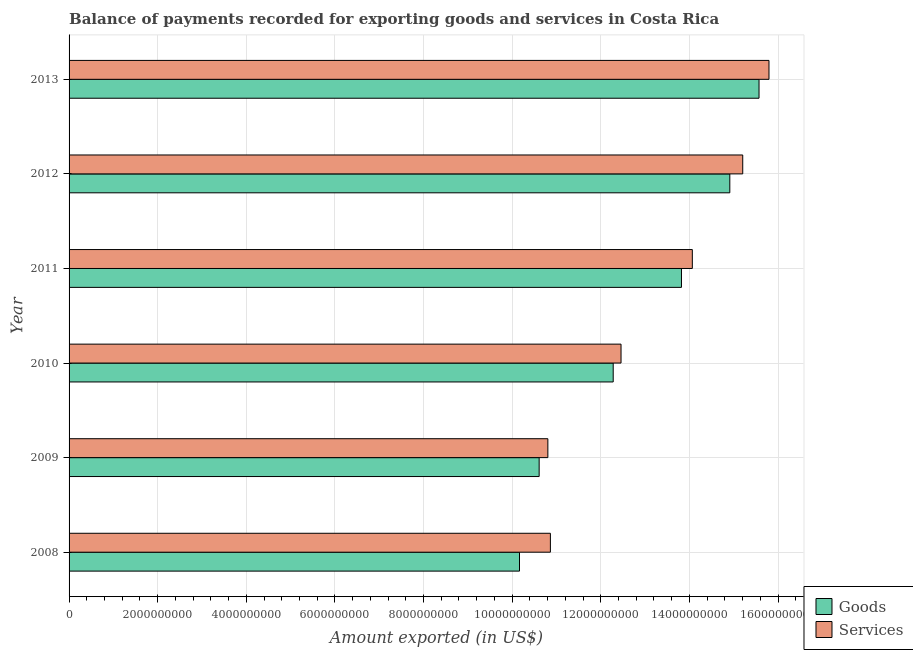How many groups of bars are there?
Provide a short and direct response. 6. How many bars are there on the 1st tick from the bottom?
Ensure brevity in your answer.  2. What is the amount of goods exported in 2011?
Your response must be concise. 1.38e+1. Across all years, what is the maximum amount of goods exported?
Offer a terse response. 1.56e+1. Across all years, what is the minimum amount of goods exported?
Ensure brevity in your answer.  1.02e+1. In which year was the amount of goods exported maximum?
Provide a short and direct response. 2013. What is the total amount of goods exported in the graph?
Your answer should be compact. 7.74e+1. What is the difference between the amount of services exported in 2009 and that in 2011?
Offer a terse response. -3.26e+09. What is the difference between the amount of goods exported in 2009 and the amount of services exported in 2011?
Offer a terse response. -3.46e+09. What is the average amount of goods exported per year?
Offer a very short reply. 1.29e+1. In the year 2009, what is the difference between the amount of services exported and amount of goods exported?
Offer a very short reply. 1.96e+08. In how many years, is the amount of goods exported greater than 2400000000 US$?
Offer a very short reply. 6. What is the ratio of the amount of goods exported in 2009 to that in 2012?
Your answer should be compact. 0.71. Is the amount of goods exported in 2009 less than that in 2010?
Provide a succinct answer. Yes. Is the difference between the amount of goods exported in 2011 and 2013 greater than the difference between the amount of services exported in 2011 and 2013?
Offer a terse response. No. What is the difference between the highest and the second highest amount of goods exported?
Your answer should be compact. 6.60e+08. What is the difference between the highest and the lowest amount of services exported?
Keep it short and to the point. 4.99e+09. In how many years, is the amount of services exported greater than the average amount of services exported taken over all years?
Offer a very short reply. 3. What does the 1st bar from the top in 2010 represents?
Keep it short and to the point. Services. What does the 1st bar from the bottom in 2008 represents?
Provide a short and direct response. Goods. How many bars are there?
Ensure brevity in your answer.  12. How many legend labels are there?
Make the answer very short. 2. What is the title of the graph?
Your answer should be very brief. Balance of payments recorded for exporting goods and services in Costa Rica. Does "Time to import" appear as one of the legend labels in the graph?
Your answer should be very brief. No. What is the label or title of the X-axis?
Provide a succinct answer. Amount exported (in US$). What is the Amount exported (in US$) of Goods in 2008?
Offer a terse response. 1.02e+1. What is the Amount exported (in US$) of Services in 2008?
Give a very brief answer. 1.09e+1. What is the Amount exported (in US$) in Goods in 2009?
Give a very brief answer. 1.06e+1. What is the Amount exported (in US$) in Services in 2009?
Your response must be concise. 1.08e+1. What is the Amount exported (in US$) in Goods in 2010?
Ensure brevity in your answer.  1.23e+1. What is the Amount exported (in US$) in Services in 2010?
Your answer should be very brief. 1.25e+1. What is the Amount exported (in US$) of Goods in 2011?
Provide a succinct answer. 1.38e+1. What is the Amount exported (in US$) in Services in 2011?
Your response must be concise. 1.41e+1. What is the Amount exported (in US$) of Goods in 2012?
Ensure brevity in your answer.  1.49e+1. What is the Amount exported (in US$) in Services in 2012?
Keep it short and to the point. 1.52e+1. What is the Amount exported (in US$) in Goods in 2013?
Provide a short and direct response. 1.56e+1. What is the Amount exported (in US$) in Services in 2013?
Make the answer very short. 1.58e+1. Across all years, what is the maximum Amount exported (in US$) of Goods?
Provide a short and direct response. 1.56e+1. Across all years, what is the maximum Amount exported (in US$) of Services?
Provide a short and direct response. 1.58e+1. Across all years, what is the minimum Amount exported (in US$) of Goods?
Give a very brief answer. 1.02e+1. Across all years, what is the minimum Amount exported (in US$) of Services?
Make the answer very short. 1.08e+1. What is the total Amount exported (in US$) of Goods in the graph?
Your answer should be very brief. 7.74e+1. What is the total Amount exported (in US$) of Services in the graph?
Keep it short and to the point. 7.92e+1. What is the difference between the Amount exported (in US$) in Goods in 2008 and that in 2009?
Your answer should be compact. -4.43e+08. What is the difference between the Amount exported (in US$) in Services in 2008 and that in 2009?
Your answer should be very brief. 5.70e+07. What is the difference between the Amount exported (in US$) in Goods in 2008 and that in 2010?
Offer a terse response. -2.11e+09. What is the difference between the Amount exported (in US$) of Services in 2008 and that in 2010?
Offer a terse response. -1.59e+09. What is the difference between the Amount exported (in US$) of Goods in 2008 and that in 2011?
Make the answer very short. -3.66e+09. What is the difference between the Amount exported (in US$) of Services in 2008 and that in 2011?
Give a very brief answer. -3.20e+09. What is the difference between the Amount exported (in US$) of Goods in 2008 and that in 2012?
Your answer should be compact. -4.75e+09. What is the difference between the Amount exported (in US$) in Services in 2008 and that in 2012?
Your answer should be very brief. -4.34e+09. What is the difference between the Amount exported (in US$) of Goods in 2008 and that in 2013?
Provide a short and direct response. -5.41e+09. What is the difference between the Amount exported (in US$) of Services in 2008 and that in 2013?
Offer a terse response. -4.93e+09. What is the difference between the Amount exported (in US$) of Goods in 2009 and that in 2010?
Give a very brief answer. -1.67e+09. What is the difference between the Amount exported (in US$) of Services in 2009 and that in 2010?
Your response must be concise. -1.65e+09. What is the difference between the Amount exported (in US$) in Goods in 2009 and that in 2011?
Provide a succinct answer. -3.21e+09. What is the difference between the Amount exported (in US$) of Services in 2009 and that in 2011?
Your response must be concise. -3.26e+09. What is the difference between the Amount exported (in US$) of Goods in 2009 and that in 2012?
Your answer should be compact. -4.30e+09. What is the difference between the Amount exported (in US$) in Services in 2009 and that in 2012?
Provide a succinct answer. -4.40e+09. What is the difference between the Amount exported (in US$) of Goods in 2009 and that in 2013?
Keep it short and to the point. -4.96e+09. What is the difference between the Amount exported (in US$) of Services in 2009 and that in 2013?
Give a very brief answer. -4.99e+09. What is the difference between the Amount exported (in US$) in Goods in 2010 and that in 2011?
Your response must be concise. -1.54e+09. What is the difference between the Amount exported (in US$) in Services in 2010 and that in 2011?
Your answer should be very brief. -1.61e+09. What is the difference between the Amount exported (in US$) in Goods in 2010 and that in 2012?
Provide a succinct answer. -2.63e+09. What is the difference between the Amount exported (in US$) in Services in 2010 and that in 2012?
Your answer should be compact. -2.75e+09. What is the difference between the Amount exported (in US$) of Goods in 2010 and that in 2013?
Give a very brief answer. -3.29e+09. What is the difference between the Amount exported (in US$) of Services in 2010 and that in 2013?
Your answer should be very brief. -3.34e+09. What is the difference between the Amount exported (in US$) in Goods in 2011 and that in 2012?
Keep it short and to the point. -1.09e+09. What is the difference between the Amount exported (in US$) of Services in 2011 and that in 2012?
Ensure brevity in your answer.  -1.14e+09. What is the difference between the Amount exported (in US$) in Goods in 2011 and that in 2013?
Ensure brevity in your answer.  -1.75e+09. What is the difference between the Amount exported (in US$) in Services in 2011 and that in 2013?
Give a very brief answer. -1.73e+09. What is the difference between the Amount exported (in US$) in Goods in 2012 and that in 2013?
Ensure brevity in your answer.  -6.60e+08. What is the difference between the Amount exported (in US$) of Services in 2012 and that in 2013?
Your answer should be very brief. -5.92e+08. What is the difference between the Amount exported (in US$) in Goods in 2008 and the Amount exported (in US$) in Services in 2009?
Ensure brevity in your answer.  -6.40e+08. What is the difference between the Amount exported (in US$) of Goods in 2008 and the Amount exported (in US$) of Services in 2010?
Provide a short and direct response. -2.29e+09. What is the difference between the Amount exported (in US$) of Goods in 2008 and the Amount exported (in US$) of Services in 2011?
Your answer should be very brief. -3.90e+09. What is the difference between the Amount exported (in US$) of Goods in 2008 and the Amount exported (in US$) of Services in 2012?
Your response must be concise. -5.04e+09. What is the difference between the Amount exported (in US$) in Goods in 2008 and the Amount exported (in US$) in Services in 2013?
Your response must be concise. -5.63e+09. What is the difference between the Amount exported (in US$) of Goods in 2009 and the Amount exported (in US$) of Services in 2010?
Your answer should be very brief. -1.85e+09. What is the difference between the Amount exported (in US$) of Goods in 2009 and the Amount exported (in US$) of Services in 2011?
Keep it short and to the point. -3.46e+09. What is the difference between the Amount exported (in US$) in Goods in 2009 and the Amount exported (in US$) in Services in 2012?
Your answer should be very brief. -4.59e+09. What is the difference between the Amount exported (in US$) of Goods in 2009 and the Amount exported (in US$) of Services in 2013?
Give a very brief answer. -5.19e+09. What is the difference between the Amount exported (in US$) in Goods in 2010 and the Amount exported (in US$) in Services in 2011?
Provide a succinct answer. -1.79e+09. What is the difference between the Amount exported (in US$) of Goods in 2010 and the Amount exported (in US$) of Services in 2012?
Your answer should be very brief. -2.92e+09. What is the difference between the Amount exported (in US$) of Goods in 2010 and the Amount exported (in US$) of Services in 2013?
Provide a succinct answer. -3.52e+09. What is the difference between the Amount exported (in US$) in Goods in 2011 and the Amount exported (in US$) in Services in 2012?
Make the answer very short. -1.38e+09. What is the difference between the Amount exported (in US$) in Goods in 2011 and the Amount exported (in US$) in Services in 2013?
Keep it short and to the point. -1.98e+09. What is the difference between the Amount exported (in US$) in Goods in 2012 and the Amount exported (in US$) in Services in 2013?
Your answer should be compact. -8.84e+08. What is the average Amount exported (in US$) of Goods per year?
Make the answer very short. 1.29e+1. What is the average Amount exported (in US$) of Services per year?
Provide a short and direct response. 1.32e+1. In the year 2008, what is the difference between the Amount exported (in US$) in Goods and Amount exported (in US$) in Services?
Offer a very short reply. -6.97e+08. In the year 2009, what is the difference between the Amount exported (in US$) of Goods and Amount exported (in US$) of Services?
Your response must be concise. -1.96e+08. In the year 2010, what is the difference between the Amount exported (in US$) of Goods and Amount exported (in US$) of Services?
Provide a succinct answer. -1.77e+08. In the year 2011, what is the difference between the Amount exported (in US$) of Goods and Amount exported (in US$) of Services?
Provide a short and direct response. -2.45e+08. In the year 2012, what is the difference between the Amount exported (in US$) of Goods and Amount exported (in US$) of Services?
Provide a succinct answer. -2.92e+08. In the year 2013, what is the difference between the Amount exported (in US$) of Goods and Amount exported (in US$) of Services?
Your response must be concise. -2.24e+08. What is the ratio of the Amount exported (in US$) in Goods in 2008 to that in 2009?
Keep it short and to the point. 0.96. What is the ratio of the Amount exported (in US$) of Services in 2008 to that in 2009?
Offer a very short reply. 1.01. What is the ratio of the Amount exported (in US$) of Goods in 2008 to that in 2010?
Provide a short and direct response. 0.83. What is the ratio of the Amount exported (in US$) in Services in 2008 to that in 2010?
Keep it short and to the point. 0.87. What is the ratio of the Amount exported (in US$) in Goods in 2008 to that in 2011?
Provide a short and direct response. 0.74. What is the ratio of the Amount exported (in US$) of Services in 2008 to that in 2011?
Provide a short and direct response. 0.77. What is the ratio of the Amount exported (in US$) in Goods in 2008 to that in 2012?
Ensure brevity in your answer.  0.68. What is the ratio of the Amount exported (in US$) in Services in 2008 to that in 2012?
Keep it short and to the point. 0.71. What is the ratio of the Amount exported (in US$) of Goods in 2008 to that in 2013?
Provide a succinct answer. 0.65. What is the ratio of the Amount exported (in US$) in Services in 2008 to that in 2013?
Provide a succinct answer. 0.69. What is the ratio of the Amount exported (in US$) in Goods in 2009 to that in 2010?
Offer a very short reply. 0.86. What is the ratio of the Amount exported (in US$) in Services in 2009 to that in 2010?
Your response must be concise. 0.87. What is the ratio of the Amount exported (in US$) in Goods in 2009 to that in 2011?
Your answer should be compact. 0.77. What is the ratio of the Amount exported (in US$) of Services in 2009 to that in 2011?
Give a very brief answer. 0.77. What is the ratio of the Amount exported (in US$) of Goods in 2009 to that in 2012?
Your response must be concise. 0.71. What is the ratio of the Amount exported (in US$) of Services in 2009 to that in 2012?
Give a very brief answer. 0.71. What is the ratio of the Amount exported (in US$) in Goods in 2009 to that in 2013?
Keep it short and to the point. 0.68. What is the ratio of the Amount exported (in US$) in Services in 2009 to that in 2013?
Offer a very short reply. 0.68. What is the ratio of the Amount exported (in US$) in Goods in 2010 to that in 2011?
Give a very brief answer. 0.89. What is the ratio of the Amount exported (in US$) of Services in 2010 to that in 2011?
Your response must be concise. 0.89. What is the ratio of the Amount exported (in US$) of Goods in 2010 to that in 2012?
Your answer should be very brief. 0.82. What is the ratio of the Amount exported (in US$) in Services in 2010 to that in 2012?
Give a very brief answer. 0.82. What is the ratio of the Amount exported (in US$) of Goods in 2010 to that in 2013?
Your answer should be very brief. 0.79. What is the ratio of the Amount exported (in US$) of Services in 2010 to that in 2013?
Offer a terse response. 0.79. What is the ratio of the Amount exported (in US$) of Goods in 2011 to that in 2012?
Ensure brevity in your answer.  0.93. What is the ratio of the Amount exported (in US$) in Services in 2011 to that in 2012?
Give a very brief answer. 0.93. What is the ratio of the Amount exported (in US$) of Goods in 2011 to that in 2013?
Provide a short and direct response. 0.89. What is the ratio of the Amount exported (in US$) of Services in 2011 to that in 2013?
Give a very brief answer. 0.89. What is the ratio of the Amount exported (in US$) in Goods in 2012 to that in 2013?
Provide a succinct answer. 0.96. What is the ratio of the Amount exported (in US$) of Services in 2012 to that in 2013?
Offer a very short reply. 0.96. What is the difference between the highest and the second highest Amount exported (in US$) of Goods?
Give a very brief answer. 6.60e+08. What is the difference between the highest and the second highest Amount exported (in US$) in Services?
Give a very brief answer. 5.92e+08. What is the difference between the highest and the lowest Amount exported (in US$) of Goods?
Provide a succinct answer. 5.41e+09. What is the difference between the highest and the lowest Amount exported (in US$) in Services?
Your answer should be compact. 4.99e+09. 